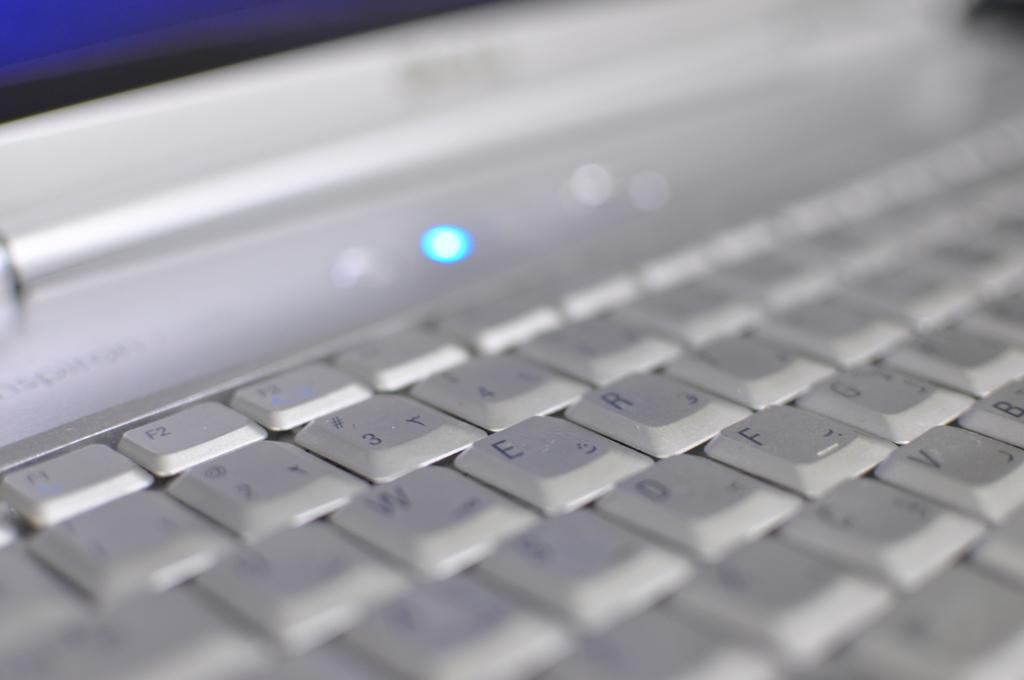<image>
Describe the image concisely. slightly blurry laptop keyboard with F1, F2, F3 visible along with numbers 1, 2, 3, 4 and also several letters visible 